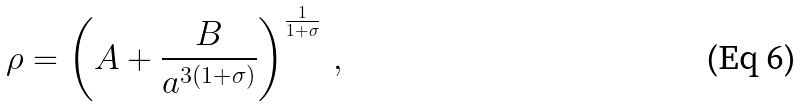<formula> <loc_0><loc_0><loc_500><loc_500>\rho = \left ( A + \frac { B } { a ^ { 3 ( 1 + \sigma ) } } \right ) ^ { \frac { 1 } { 1 + \sigma } } \, ,</formula> 